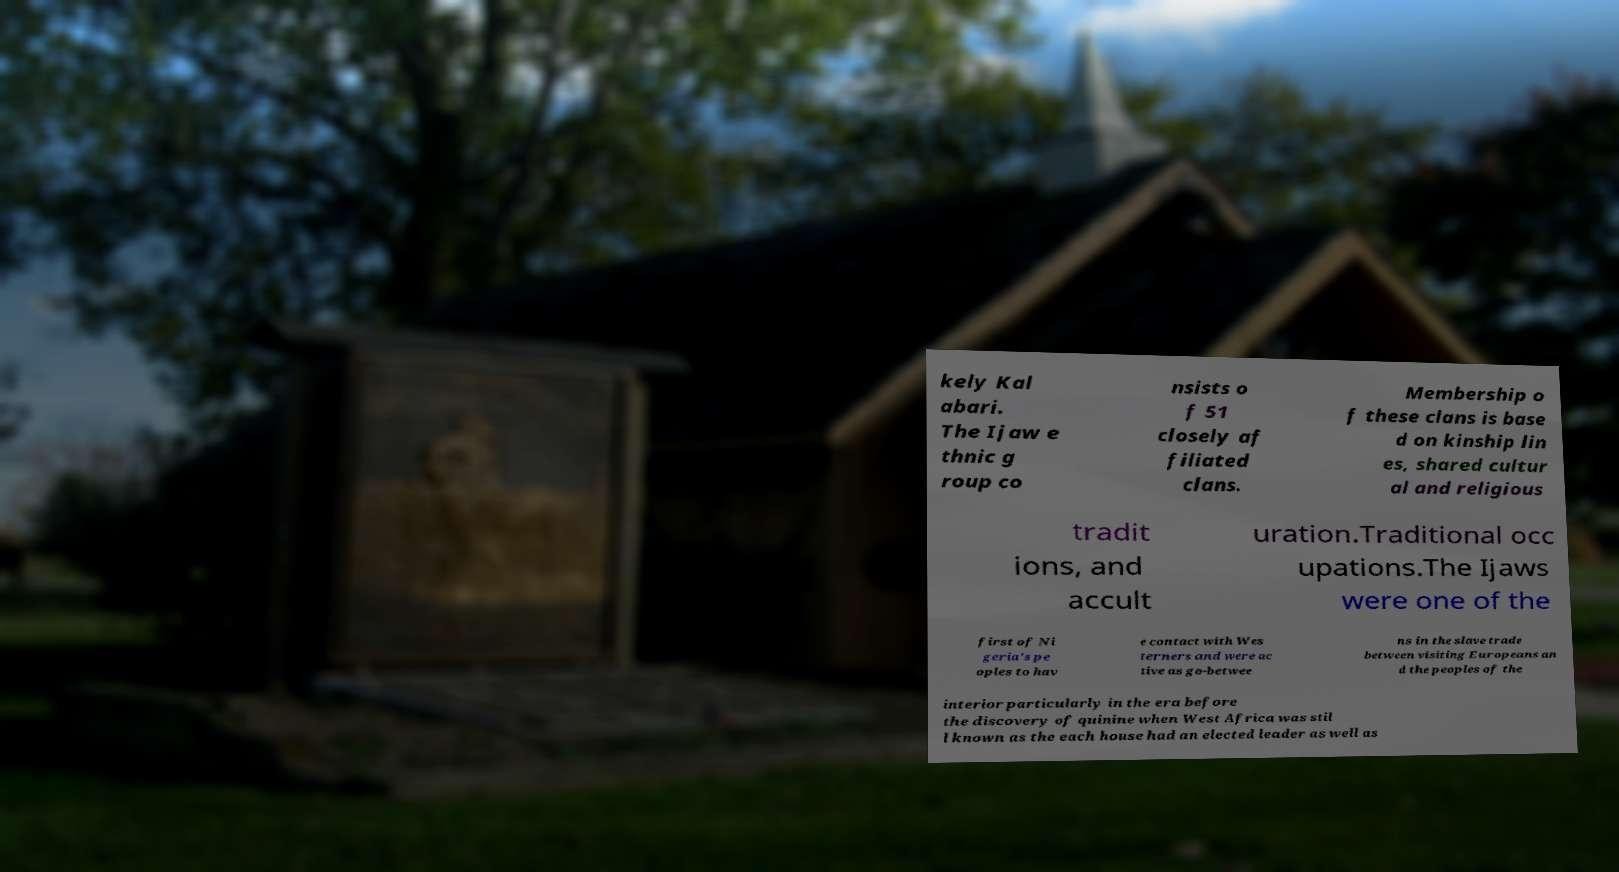Could you extract and type out the text from this image? kely Kal abari. The Ijaw e thnic g roup co nsists o f 51 closely af filiated clans. Membership o f these clans is base d on kinship lin es, shared cultur al and religious tradit ions, and accult uration.Traditional occ upations.The Ijaws were one of the first of Ni geria's pe oples to hav e contact with Wes terners and were ac tive as go-betwee ns in the slave trade between visiting Europeans an d the peoples of the interior particularly in the era before the discovery of quinine when West Africa was stil l known as the each house had an elected leader as well as 